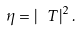Convert formula to latex. <formula><loc_0><loc_0><loc_500><loc_500>\eta = \left | \ T \right | ^ { 2 } .</formula> 